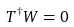<formula> <loc_0><loc_0><loc_500><loc_500>T ^ { \dag } W = 0</formula> 